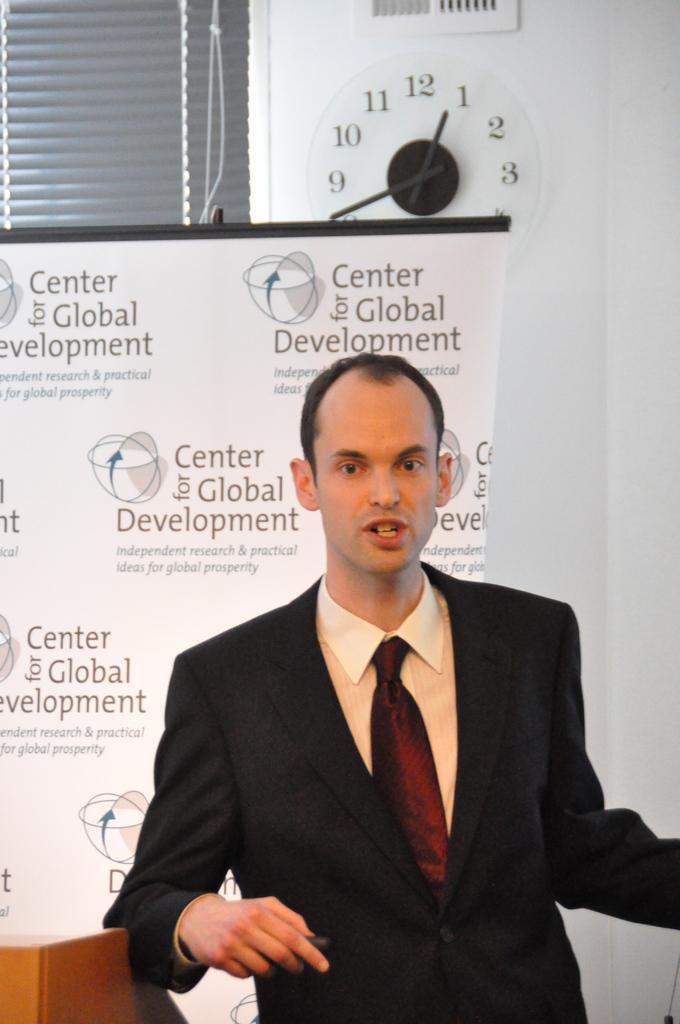Could you give a brief overview of what you see in this image? In the picture I can see a man is standing. The man is wearing a tie, a shirt and black color coat. In the background I can see window blinds, a clock on the wall and a banner which has something written on it. 